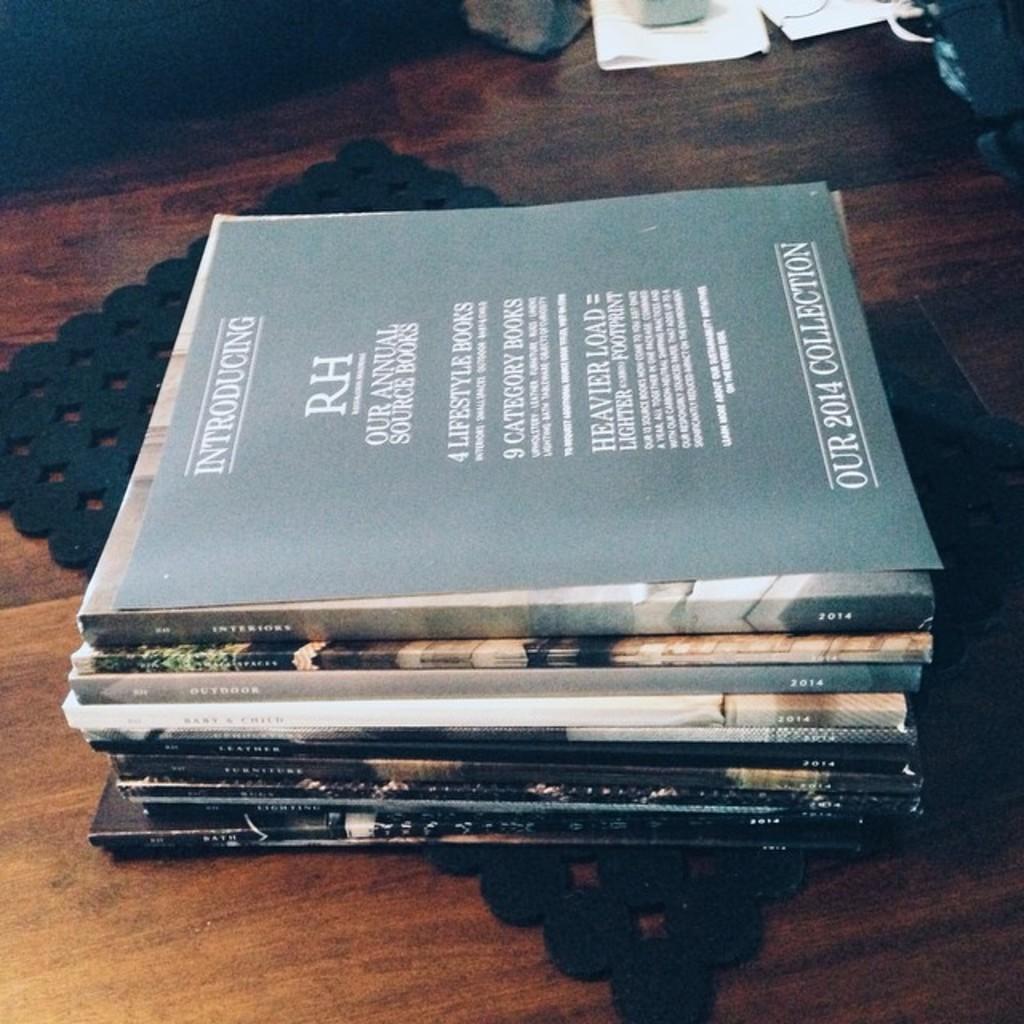Who published this collection?
Offer a very short reply. Rh. 